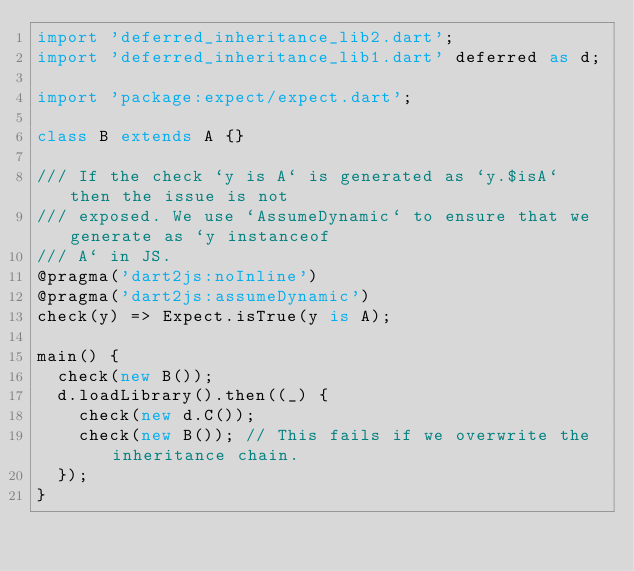<code> <loc_0><loc_0><loc_500><loc_500><_Dart_>import 'deferred_inheritance_lib2.dart';
import 'deferred_inheritance_lib1.dart' deferred as d;

import 'package:expect/expect.dart';

class B extends A {}

/// If the check `y is A` is generated as `y.$isA` then the issue is not
/// exposed. We use `AssumeDynamic` to ensure that we generate as `y instanceof
/// A` in JS.
@pragma('dart2js:noInline')
@pragma('dart2js:assumeDynamic')
check(y) => Expect.isTrue(y is A);

main() {
  check(new B());
  d.loadLibrary().then((_) {
    check(new d.C());
    check(new B()); // This fails if we overwrite the inheritance chain.
  });
}
</code> 